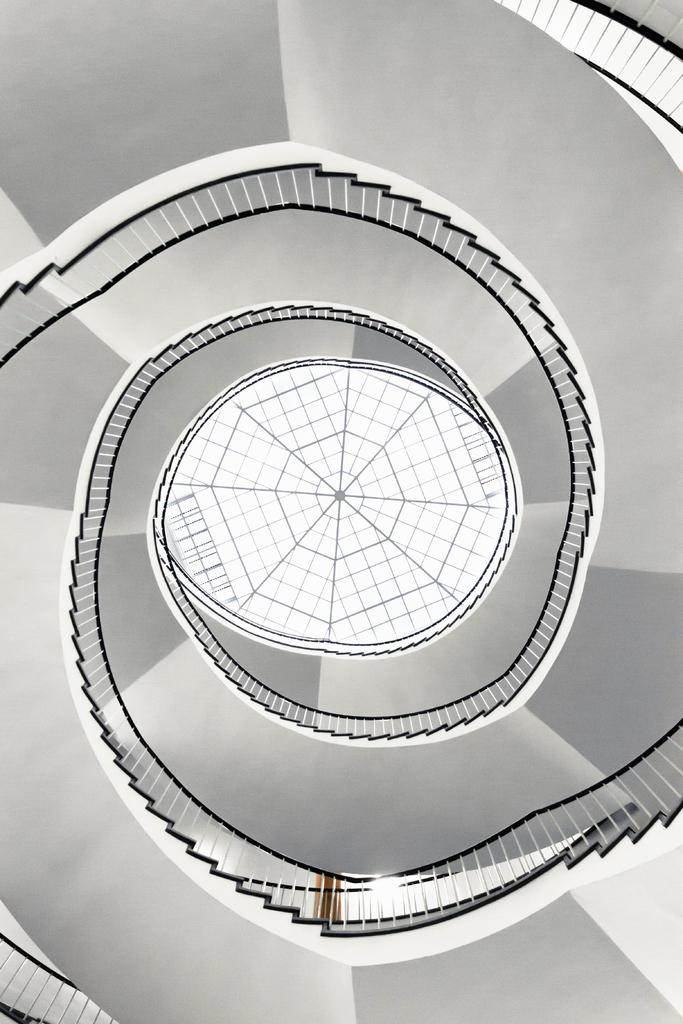What is the main structure in the middle of the picture? There is a staircase in the middle of the picture. What feature is associated with the staircase? There is a railing associated with the staircase. How many cents are visible on the staircase in the image? There are no cents visible on the staircase in the image. What type of battle is taking place on the staircase in the image? There is no battle taking place on the staircase in the image. 